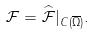Convert formula to latex. <formula><loc_0><loc_0><loc_500><loc_500>\mathcal { F } = \widehat { \mathcal { F } } | _ { C ( \overline { \Omega } ) } .</formula> 